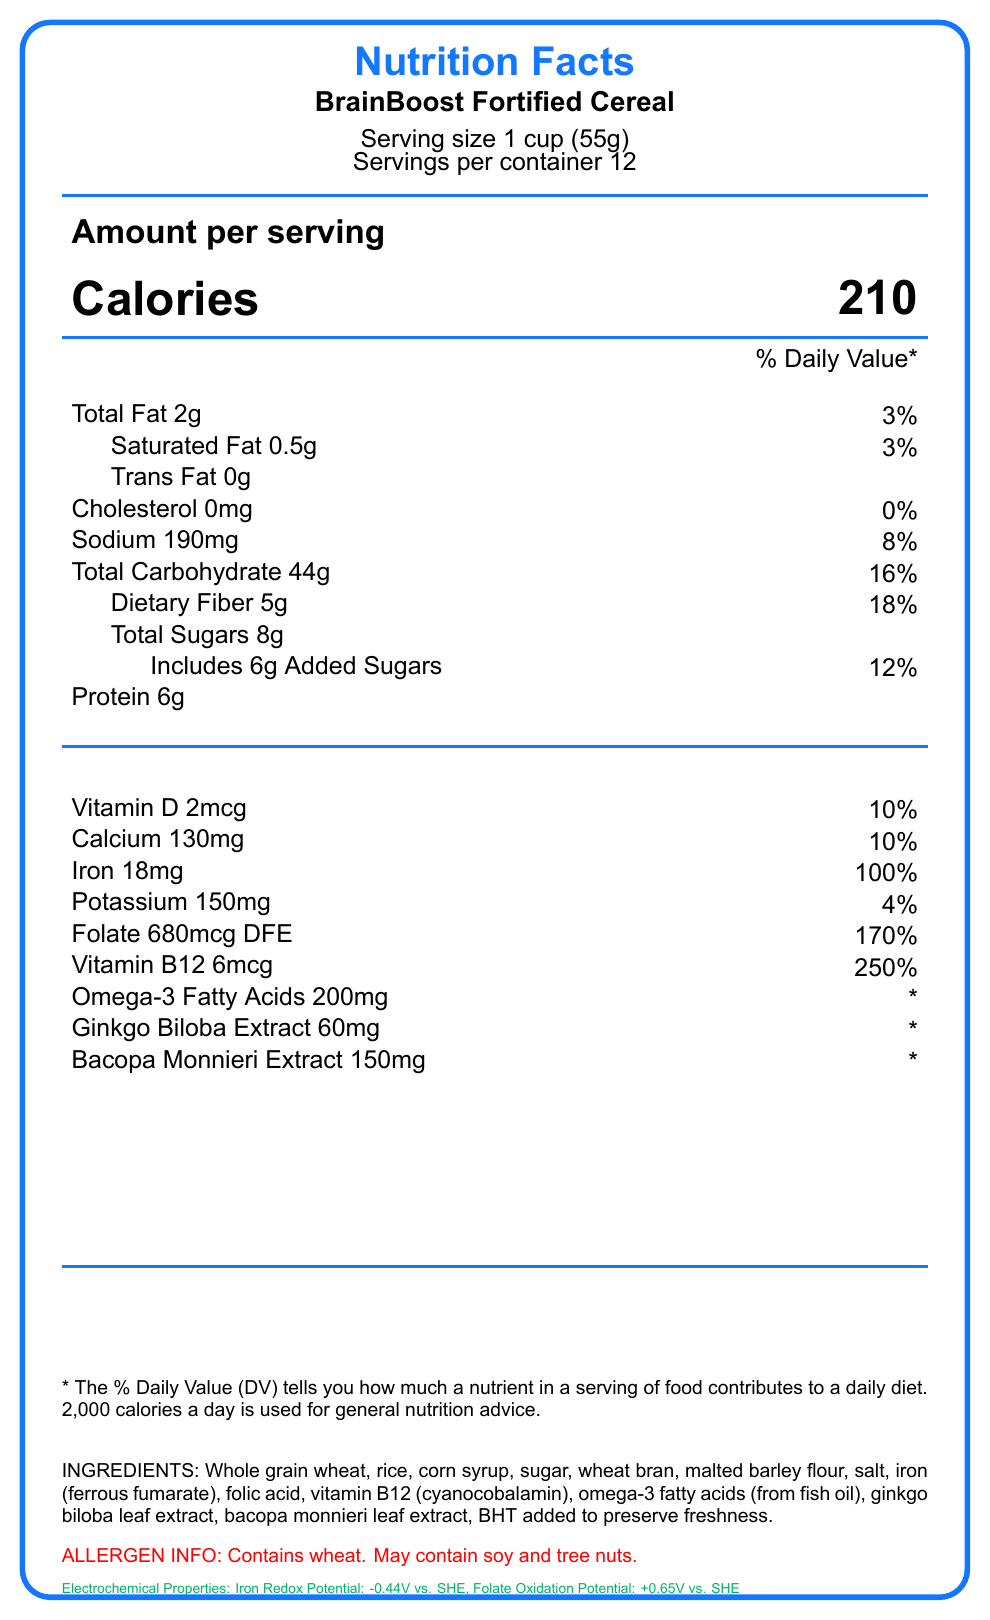what is the serving size? The serving size is clearly stated at the top of the document under the product name "BrainBoost Fortified Cereal".
Answer: 1 cup (55g) how many calories are in one serving? The calories per serving are listed in the "Amount per serving" section below the serving size information.
Answer: 210 what is the percentage of the Daily Value for iron per serving? The percentage of the Daily Value for iron is listed next to the amount per serving, which is 18mg.
Answer: 100% how many grams of dietary fiber are in one serving? The amount of dietary fiber per serving is listed in the nutrition facts under "Total Carbohydrate".
Answer: 5g what are the two main ingredients used to fortify the cereal for cognitive performance? The ingredients include "iron (ferrous fumarate)" and "folic acid", which are known to support cognitive performance.
Answer: Iron (ferrous fumarate) and folic acid how does the cereal help in improving mental clarity? The document mentions the high iron and folate content, which are essential for cognitive health.
Answer: The cereal is fortified with iron and folate which improve cognitive performance how much protein is in one serving? The protein content per serving is listed in the nutrition facts label.
Answer: 6g which vitamins are included in BrainBoost Fortified Cereal? A. Vitamin C and E B. Vitamin D and B12 C. Vitamin A and K D. Vitamin B6 and B9 The document lists Vitamin D (2mcg) and Vitamin B12 (6mcg) in the nutrition facts section.
Answer: B what is the redox potential of iron in the cereal? A. -0.44V vs. SHE B. +0.65V vs. SHE C. +0.25V vs. SHE D. -0.33V vs. SHE The electrochemical properties section lists the redox potential of iron as -0.44V vs. SHE.
Answer: A are there any trans fats in this cereal? The nutrition facts label lists "Trans Fat 0g", meaning there are no trans fats in the cereal.
Answer: No is there a risk for people with nut allergies consuming this cereal? The allergen information indicates the cereal may contain tree nuts, posing a risk for people with nut allergies.
Answer: Yes summarize the main idea of the document. The document covers the nutritional content of the cereal, specifies ingredients and allergens, highlights electrochemical properties, and suggests the cereal is fortified to support cognitive health.
Answer: The document provides detailed nutrition facts for BrainBoost Fortified Cereal, emphasizing its high iron and folate content designed to improve focus and mental clarity. It also includes unique ingredients like omega-3 fatty acids, ginkgo biloba extract, and bacopa monnieri extract. The cereal’s electrochemical properties make it suitable for novel nutritional content analysis using voltammetric techniques. how much calcium is in one serving, and what percentage of the Daily Value does it represent? The nutrition facts section lists 130mg of calcium per serving, which is 10% of the Daily Value.
Answer: 130mg, 10% how much folate is present in one serving of the cereal in terms of Daily Folate Equivalents (DFE)? The amount of folate in the cereal is listed as 680mcg DFE in the nutrition facts section.
Answer: 680mcg DFE what is the daily value percentage for vitamin B12 in one serving? The percentage of the Daily Value for vitamin B12 is listed as 250% per serving.
Answer: 250% how many grams of added sugars are included in one serving? The nutrition facts label indicates there are 6g of added sugars per serving.
Answer: 6g does the document give enough information to determine the origin of the omega-3 fatty acids? The ingredients list specifies "omega-3 fatty acids (from fish oil)". The origin of the omega-3 fatty acids is provided.
Answer: Yes can the electrochemical properties of the cereal be analyzed using voltammetric techniques? The document mentions that high iron and folate content allows for potential electrochemical detection using voltammetric techniques, highlighting diagnostic tool relevance.
Answer: Yes is the product safe for someone with soy allergies? The allergen information states that the cereal "may contain soy," but it doesn't provide enough information to confirm absence or presence of soy.
Answer: Cannot be determined 